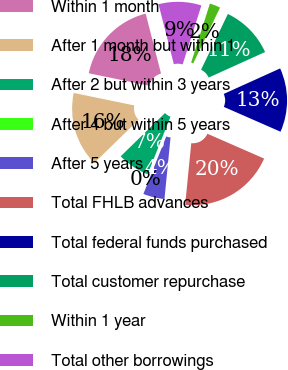<chart> <loc_0><loc_0><loc_500><loc_500><pie_chart><fcel>Within 1 month<fcel>After 1 month but within 1<fcel>After 2 but within 3 years<fcel>After 4 but within 5 years<fcel>After 5 years<fcel>Total FHLB advances<fcel>Total federal funds purchased<fcel>Total customer repurchase<fcel>Within 1 year<fcel>Total other borrowings<nl><fcel>17.77%<fcel>15.55%<fcel>6.67%<fcel>0.0%<fcel>4.45%<fcel>20.0%<fcel>13.33%<fcel>11.11%<fcel>2.23%<fcel>8.89%<nl></chart> 